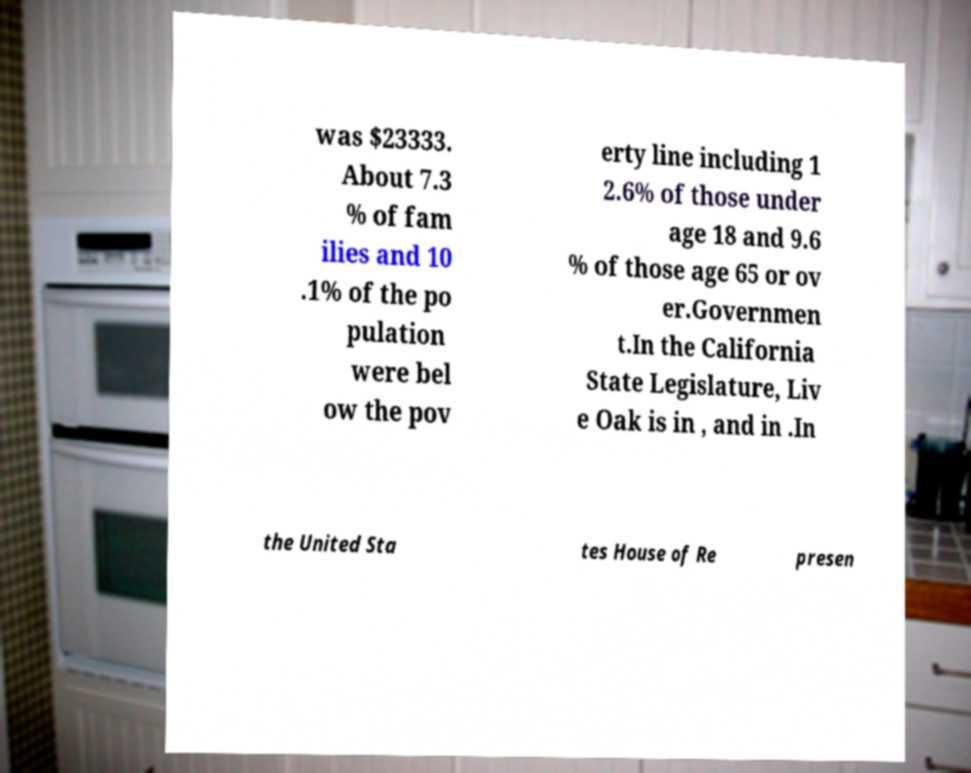Could you assist in decoding the text presented in this image and type it out clearly? was $23333. About 7.3 % of fam ilies and 10 .1% of the po pulation were bel ow the pov erty line including 1 2.6% of those under age 18 and 9.6 % of those age 65 or ov er.Governmen t.In the California State Legislature, Liv e Oak is in , and in .In the United Sta tes House of Re presen 